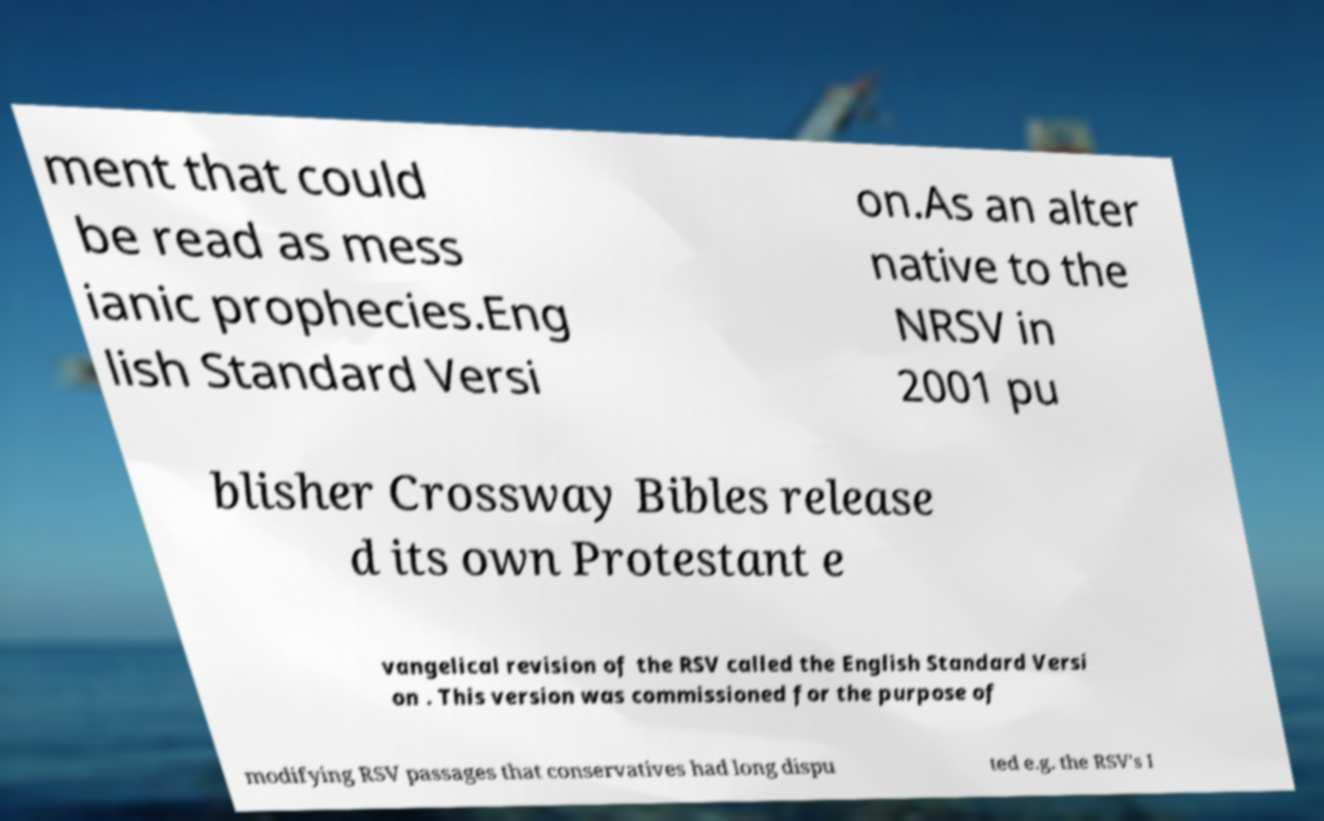For documentation purposes, I need the text within this image transcribed. Could you provide that? ment that could be read as mess ianic prophecies.Eng lish Standard Versi on.As an alter native to the NRSV in 2001 pu blisher Crossway Bibles release d its own Protestant e vangelical revision of the RSV called the English Standard Versi on . This version was commissioned for the purpose of modifying RSV passages that conservatives had long dispu ted e.g. the RSV's I 